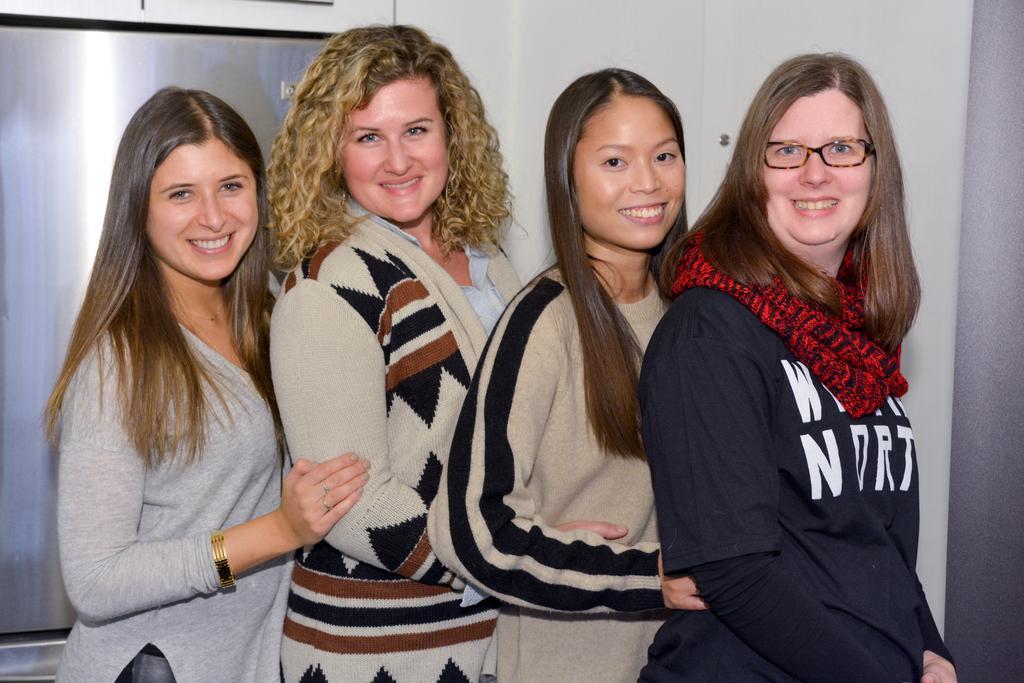Describe this image in one or two sentences. In the middle of the image few women are standing and smiling. Behind them there is a wall. 